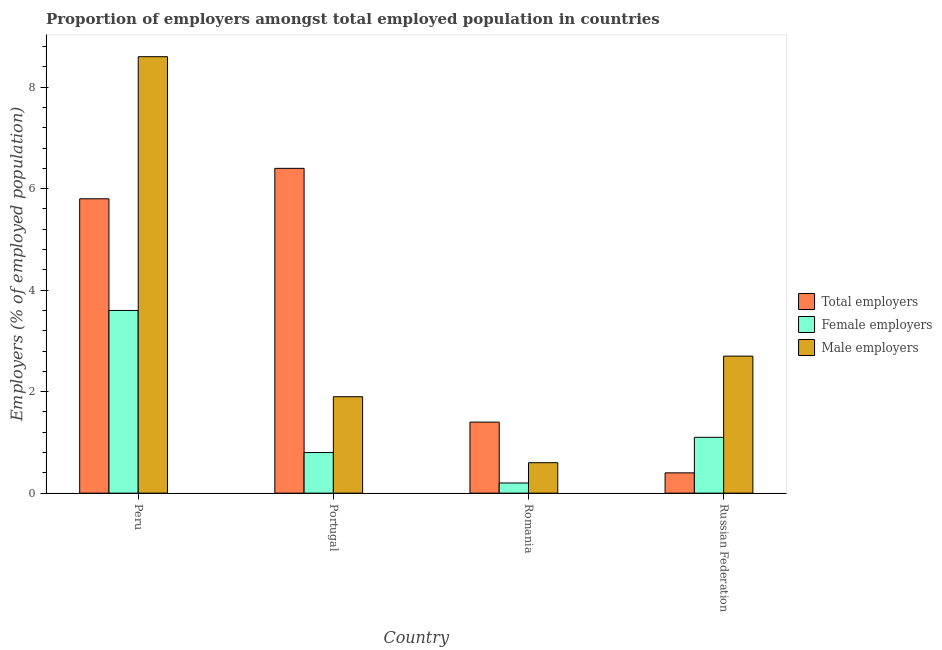How many groups of bars are there?
Provide a succinct answer. 4. How many bars are there on the 2nd tick from the right?
Provide a succinct answer. 3. What is the label of the 2nd group of bars from the left?
Make the answer very short. Portugal. In how many cases, is the number of bars for a given country not equal to the number of legend labels?
Your answer should be very brief. 0. What is the percentage of male employers in Russian Federation?
Make the answer very short. 2.7. Across all countries, what is the maximum percentage of female employers?
Keep it short and to the point. 3.6. Across all countries, what is the minimum percentage of male employers?
Your answer should be very brief. 0.6. In which country was the percentage of female employers maximum?
Offer a terse response. Peru. In which country was the percentage of female employers minimum?
Ensure brevity in your answer.  Romania. What is the total percentage of male employers in the graph?
Provide a short and direct response. 13.8. What is the difference between the percentage of male employers in Portugal and that in Russian Federation?
Offer a terse response. -0.8. What is the difference between the percentage of male employers in Portugal and the percentage of female employers in Russian Federation?
Your answer should be compact. 0.8. What is the average percentage of total employers per country?
Provide a succinct answer. 3.5. What is the difference between the percentage of female employers and percentage of total employers in Romania?
Offer a terse response. -1.2. What is the ratio of the percentage of total employers in Portugal to that in Russian Federation?
Make the answer very short. 16. What is the difference between the highest and the second highest percentage of male employers?
Give a very brief answer. 5.9. What is the difference between the highest and the lowest percentage of total employers?
Make the answer very short. 6. What does the 2nd bar from the left in Romania represents?
Your response must be concise. Female employers. What does the 3rd bar from the right in Portugal represents?
Give a very brief answer. Total employers. Is it the case that in every country, the sum of the percentage of total employers and percentage of female employers is greater than the percentage of male employers?
Keep it short and to the point. No. How many bars are there?
Offer a very short reply. 12. Are all the bars in the graph horizontal?
Make the answer very short. No. What is the difference between two consecutive major ticks on the Y-axis?
Offer a very short reply. 2. Are the values on the major ticks of Y-axis written in scientific E-notation?
Provide a succinct answer. No. Does the graph contain grids?
Your response must be concise. No. How are the legend labels stacked?
Keep it short and to the point. Vertical. What is the title of the graph?
Provide a short and direct response. Proportion of employers amongst total employed population in countries. What is the label or title of the Y-axis?
Offer a terse response. Employers (% of employed population). What is the Employers (% of employed population) in Total employers in Peru?
Keep it short and to the point. 5.8. What is the Employers (% of employed population) of Female employers in Peru?
Provide a short and direct response. 3.6. What is the Employers (% of employed population) of Male employers in Peru?
Your response must be concise. 8.6. What is the Employers (% of employed population) in Total employers in Portugal?
Make the answer very short. 6.4. What is the Employers (% of employed population) of Female employers in Portugal?
Keep it short and to the point. 0.8. What is the Employers (% of employed population) in Male employers in Portugal?
Give a very brief answer. 1.9. What is the Employers (% of employed population) of Total employers in Romania?
Your response must be concise. 1.4. What is the Employers (% of employed population) in Female employers in Romania?
Provide a short and direct response. 0.2. What is the Employers (% of employed population) in Male employers in Romania?
Offer a terse response. 0.6. What is the Employers (% of employed population) in Total employers in Russian Federation?
Your answer should be compact. 0.4. What is the Employers (% of employed population) of Female employers in Russian Federation?
Offer a very short reply. 1.1. What is the Employers (% of employed population) in Male employers in Russian Federation?
Offer a terse response. 2.7. Across all countries, what is the maximum Employers (% of employed population) of Total employers?
Ensure brevity in your answer.  6.4. Across all countries, what is the maximum Employers (% of employed population) of Female employers?
Make the answer very short. 3.6. Across all countries, what is the maximum Employers (% of employed population) of Male employers?
Your answer should be very brief. 8.6. Across all countries, what is the minimum Employers (% of employed population) of Total employers?
Offer a terse response. 0.4. Across all countries, what is the minimum Employers (% of employed population) of Female employers?
Your answer should be very brief. 0.2. Across all countries, what is the minimum Employers (% of employed population) in Male employers?
Keep it short and to the point. 0.6. What is the difference between the Employers (% of employed population) in Total employers in Peru and that in Portugal?
Offer a very short reply. -0.6. What is the difference between the Employers (% of employed population) in Male employers in Peru and that in Portugal?
Give a very brief answer. 6.7. What is the difference between the Employers (% of employed population) of Total employers in Peru and that in Romania?
Provide a succinct answer. 4.4. What is the difference between the Employers (% of employed population) of Female employers in Peru and that in Romania?
Keep it short and to the point. 3.4. What is the difference between the Employers (% of employed population) of Total employers in Peru and that in Russian Federation?
Offer a terse response. 5.4. What is the difference between the Employers (% of employed population) in Male employers in Peru and that in Russian Federation?
Offer a very short reply. 5.9. What is the difference between the Employers (% of employed population) in Total employers in Portugal and that in Romania?
Make the answer very short. 5. What is the difference between the Employers (% of employed population) of Female employers in Portugal and that in Russian Federation?
Your answer should be compact. -0.3. What is the difference between the Employers (% of employed population) in Total employers in Romania and that in Russian Federation?
Give a very brief answer. 1. What is the difference between the Employers (% of employed population) in Total employers in Peru and the Employers (% of employed population) in Female employers in Portugal?
Offer a very short reply. 5. What is the difference between the Employers (% of employed population) in Total employers in Peru and the Employers (% of employed population) in Male employers in Portugal?
Your answer should be compact. 3.9. What is the difference between the Employers (% of employed population) of Total employers in Peru and the Employers (% of employed population) of Female employers in Romania?
Offer a terse response. 5.6. What is the difference between the Employers (% of employed population) in Female employers in Peru and the Employers (% of employed population) in Male employers in Romania?
Make the answer very short. 3. What is the difference between the Employers (% of employed population) of Total employers in Peru and the Employers (% of employed population) of Female employers in Russian Federation?
Keep it short and to the point. 4.7. What is the difference between the Employers (% of employed population) of Total employers in Portugal and the Employers (% of employed population) of Female employers in Romania?
Keep it short and to the point. 6.2. What is the difference between the Employers (% of employed population) in Total employers in Portugal and the Employers (% of employed population) in Male employers in Romania?
Give a very brief answer. 5.8. What is the difference between the Employers (% of employed population) of Total employers in Portugal and the Employers (% of employed population) of Female employers in Russian Federation?
Make the answer very short. 5.3. What is the difference between the Employers (% of employed population) in Total employers in Portugal and the Employers (% of employed population) in Male employers in Russian Federation?
Keep it short and to the point. 3.7. What is the difference between the Employers (% of employed population) of Total employers in Romania and the Employers (% of employed population) of Female employers in Russian Federation?
Make the answer very short. 0.3. What is the difference between the Employers (% of employed population) of Total employers in Romania and the Employers (% of employed population) of Male employers in Russian Federation?
Your answer should be very brief. -1.3. What is the average Employers (% of employed population) in Female employers per country?
Keep it short and to the point. 1.43. What is the average Employers (% of employed population) of Male employers per country?
Provide a succinct answer. 3.45. What is the difference between the Employers (% of employed population) of Total employers and Employers (% of employed population) of Female employers in Peru?
Provide a succinct answer. 2.2. What is the difference between the Employers (% of employed population) in Total employers and Employers (% of employed population) in Male employers in Peru?
Offer a very short reply. -2.8. What is the difference between the Employers (% of employed population) in Total employers and Employers (% of employed population) in Female employers in Portugal?
Make the answer very short. 5.6. What is the difference between the Employers (% of employed population) of Total employers and Employers (% of employed population) of Male employers in Portugal?
Ensure brevity in your answer.  4.5. What is the difference between the Employers (% of employed population) of Female employers and Employers (% of employed population) of Male employers in Russian Federation?
Your answer should be very brief. -1.6. What is the ratio of the Employers (% of employed population) in Total employers in Peru to that in Portugal?
Your answer should be very brief. 0.91. What is the ratio of the Employers (% of employed population) in Female employers in Peru to that in Portugal?
Offer a very short reply. 4.5. What is the ratio of the Employers (% of employed population) in Male employers in Peru to that in Portugal?
Provide a short and direct response. 4.53. What is the ratio of the Employers (% of employed population) in Total employers in Peru to that in Romania?
Offer a very short reply. 4.14. What is the ratio of the Employers (% of employed population) in Male employers in Peru to that in Romania?
Ensure brevity in your answer.  14.33. What is the ratio of the Employers (% of employed population) of Total employers in Peru to that in Russian Federation?
Give a very brief answer. 14.5. What is the ratio of the Employers (% of employed population) of Female employers in Peru to that in Russian Federation?
Give a very brief answer. 3.27. What is the ratio of the Employers (% of employed population) of Male employers in Peru to that in Russian Federation?
Provide a short and direct response. 3.19. What is the ratio of the Employers (% of employed population) of Total employers in Portugal to that in Romania?
Ensure brevity in your answer.  4.57. What is the ratio of the Employers (% of employed population) of Male employers in Portugal to that in Romania?
Ensure brevity in your answer.  3.17. What is the ratio of the Employers (% of employed population) of Female employers in Portugal to that in Russian Federation?
Keep it short and to the point. 0.73. What is the ratio of the Employers (% of employed population) in Male employers in Portugal to that in Russian Federation?
Your response must be concise. 0.7. What is the ratio of the Employers (% of employed population) in Total employers in Romania to that in Russian Federation?
Provide a succinct answer. 3.5. What is the ratio of the Employers (% of employed population) of Female employers in Romania to that in Russian Federation?
Ensure brevity in your answer.  0.18. What is the ratio of the Employers (% of employed population) of Male employers in Romania to that in Russian Federation?
Make the answer very short. 0.22. What is the difference between the highest and the second highest Employers (% of employed population) in Total employers?
Ensure brevity in your answer.  0.6. What is the difference between the highest and the second highest Employers (% of employed population) in Female employers?
Offer a terse response. 2.5. What is the difference between the highest and the lowest Employers (% of employed population) in Female employers?
Give a very brief answer. 3.4. 